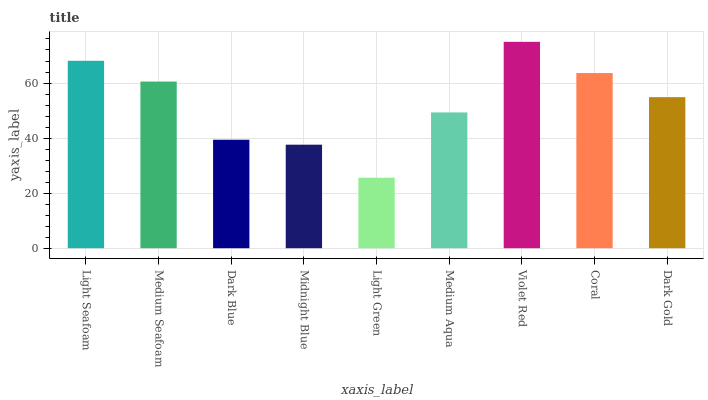Is Light Green the minimum?
Answer yes or no. Yes. Is Violet Red the maximum?
Answer yes or no. Yes. Is Medium Seafoam the minimum?
Answer yes or no. No. Is Medium Seafoam the maximum?
Answer yes or no. No. Is Light Seafoam greater than Medium Seafoam?
Answer yes or no. Yes. Is Medium Seafoam less than Light Seafoam?
Answer yes or no. Yes. Is Medium Seafoam greater than Light Seafoam?
Answer yes or no. No. Is Light Seafoam less than Medium Seafoam?
Answer yes or no. No. Is Dark Gold the high median?
Answer yes or no. Yes. Is Dark Gold the low median?
Answer yes or no. Yes. Is Coral the high median?
Answer yes or no. No. Is Light Green the low median?
Answer yes or no. No. 